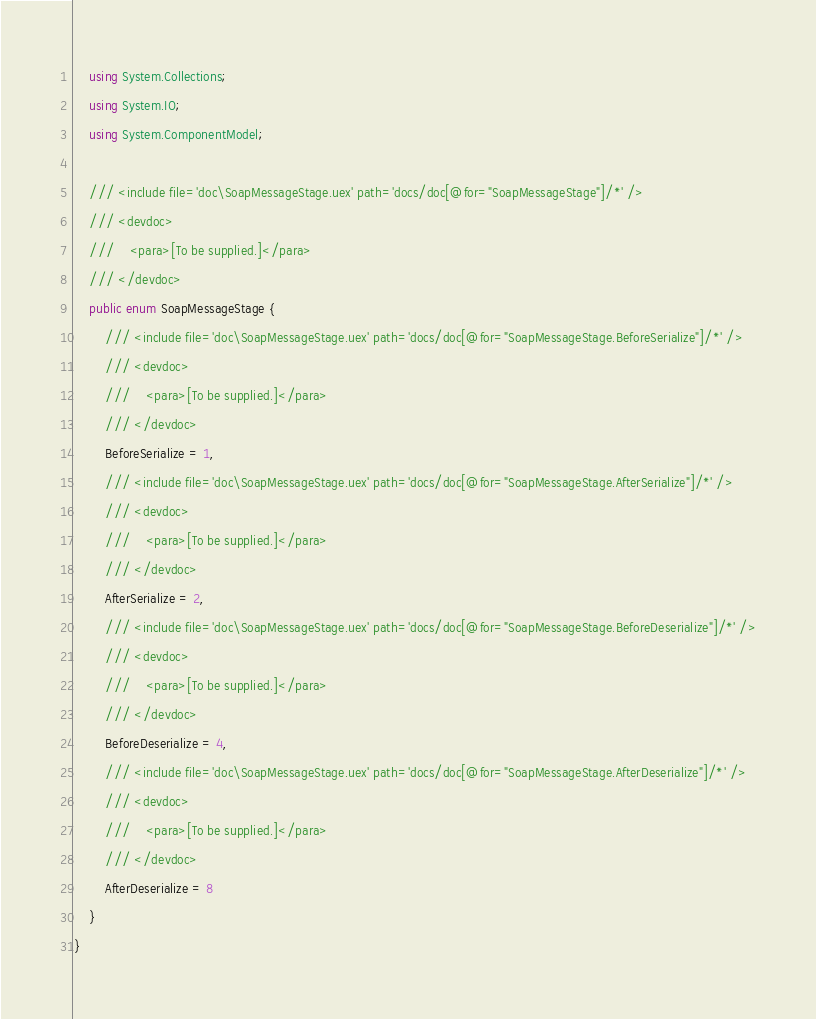<code> <loc_0><loc_0><loc_500><loc_500><_C#_>    using System.Collections;
    using System.IO;
    using System.ComponentModel;

    /// <include file='doc\SoapMessageStage.uex' path='docs/doc[@for="SoapMessageStage"]/*' />
    /// <devdoc>
    ///    <para>[To be supplied.]</para>
    /// </devdoc>
    public enum SoapMessageStage {
        /// <include file='doc\SoapMessageStage.uex' path='docs/doc[@for="SoapMessageStage.BeforeSerialize"]/*' />
        /// <devdoc>
        ///    <para>[To be supplied.]</para>
        /// </devdoc>
        BeforeSerialize = 1,
        /// <include file='doc\SoapMessageStage.uex' path='docs/doc[@for="SoapMessageStage.AfterSerialize"]/*' />
        /// <devdoc>
        ///    <para>[To be supplied.]</para>
        /// </devdoc>
        AfterSerialize = 2,
        /// <include file='doc\SoapMessageStage.uex' path='docs/doc[@for="SoapMessageStage.BeforeDeserialize"]/*' />
        /// <devdoc>
        ///    <para>[To be supplied.]</para>
        /// </devdoc>
        BeforeDeserialize = 4,
        /// <include file='doc\SoapMessageStage.uex' path='docs/doc[@for="SoapMessageStage.AfterDeserialize"]/*' />
        /// <devdoc>
        ///    <para>[To be supplied.]</para>
        /// </devdoc>
        AfterDeserialize = 8
    }
}
</code> 